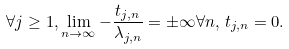<formula> <loc_0><loc_0><loc_500><loc_500>\forall j \geq 1 , \lim _ { n \rightarrow \infty } - \frac { t _ { j , n } } { \lambda _ { j , n } } = \pm \infty \forall n , \, t _ { j , n } = 0 .</formula> 